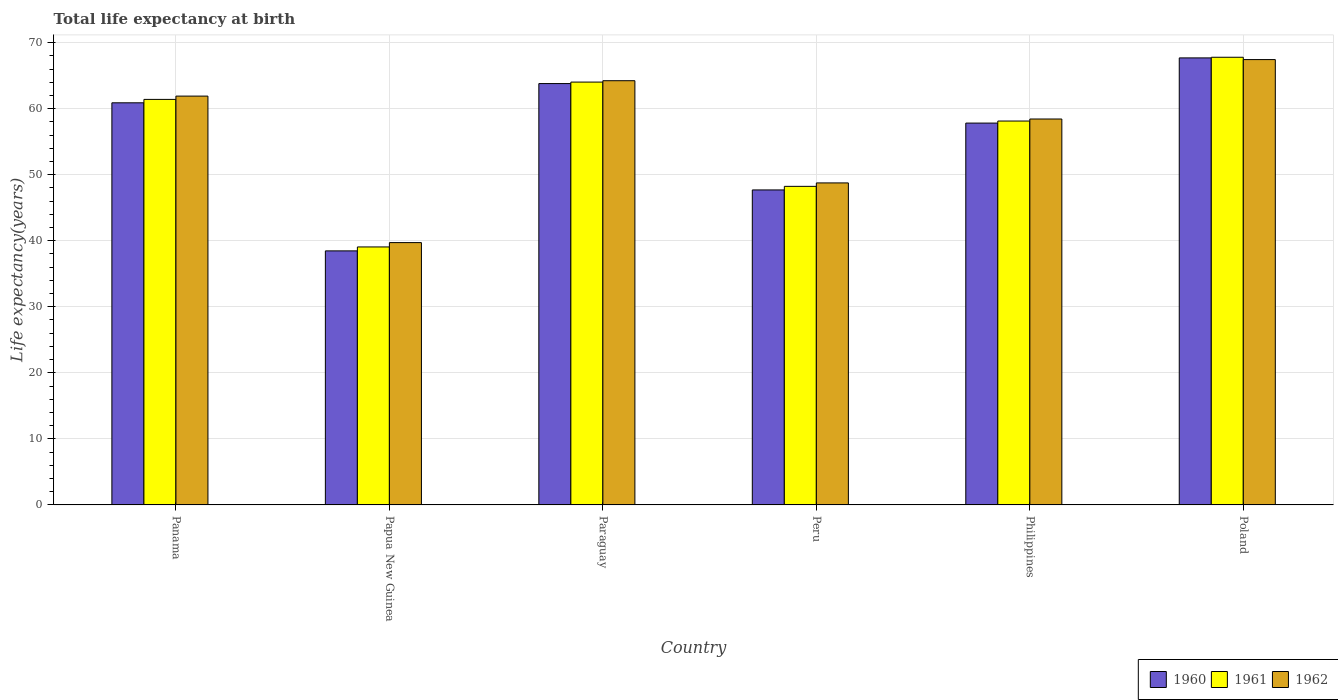How many different coloured bars are there?
Provide a succinct answer. 3. How many groups of bars are there?
Your answer should be very brief. 6. Are the number of bars per tick equal to the number of legend labels?
Offer a terse response. Yes. How many bars are there on the 6th tick from the right?
Offer a terse response. 3. What is the label of the 1st group of bars from the left?
Give a very brief answer. Panama. What is the life expectancy at birth in in 1960 in Panama?
Provide a succinct answer. 60.88. Across all countries, what is the maximum life expectancy at birth in in 1961?
Your answer should be compact. 67.78. Across all countries, what is the minimum life expectancy at birth in in 1961?
Offer a terse response. 39.06. In which country was the life expectancy at birth in in 1960 maximum?
Keep it short and to the point. Poland. In which country was the life expectancy at birth in in 1962 minimum?
Your response must be concise. Papua New Guinea. What is the total life expectancy at birth in in 1962 in the graph?
Offer a very short reply. 340.45. What is the difference between the life expectancy at birth in in 1962 in Panama and that in Papua New Guinea?
Keep it short and to the point. 22.18. What is the difference between the life expectancy at birth in in 1962 in Peru and the life expectancy at birth in in 1961 in Paraguay?
Offer a terse response. -15.27. What is the average life expectancy at birth in in 1961 per country?
Give a very brief answer. 56.43. What is the difference between the life expectancy at birth in of/in 1960 and life expectancy at birth in of/in 1962 in Philippines?
Your answer should be compact. -0.62. What is the ratio of the life expectancy at birth in in 1962 in Panama to that in Peru?
Ensure brevity in your answer.  1.27. What is the difference between the highest and the second highest life expectancy at birth in in 1962?
Offer a terse response. -3.2. What is the difference between the highest and the lowest life expectancy at birth in in 1960?
Provide a succinct answer. 29.22. In how many countries, is the life expectancy at birth in in 1960 greater than the average life expectancy at birth in in 1960 taken over all countries?
Your answer should be very brief. 4. Is the sum of the life expectancy at birth in in 1962 in Panama and Poland greater than the maximum life expectancy at birth in in 1961 across all countries?
Your answer should be very brief. Yes. How many bars are there?
Your response must be concise. 18. Does the graph contain any zero values?
Ensure brevity in your answer.  No. Where does the legend appear in the graph?
Give a very brief answer. Bottom right. What is the title of the graph?
Make the answer very short. Total life expectancy at birth. Does "1987" appear as one of the legend labels in the graph?
Offer a very short reply. No. What is the label or title of the X-axis?
Provide a short and direct response. Country. What is the label or title of the Y-axis?
Give a very brief answer. Life expectancy(years). What is the Life expectancy(years) of 1960 in Panama?
Provide a short and direct response. 60.88. What is the Life expectancy(years) of 1961 in Panama?
Provide a short and direct response. 61.4. What is the Life expectancy(years) in 1962 in Panama?
Your response must be concise. 61.9. What is the Life expectancy(years) of 1960 in Papua New Guinea?
Give a very brief answer. 38.46. What is the Life expectancy(years) of 1961 in Papua New Guinea?
Your answer should be compact. 39.06. What is the Life expectancy(years) of 1962 in Papua New Guinea?
Your answer should be very brief. 39.72. What is the Life expectancy(years) in 1960 in Paraguay?
Ensure brevity in your answer.  63.79. What is the Life expectancy(years) of 1961 in Paraguay?
Provide a short and direct response. 64.02. What is the Life expectancy(years) in 1962 in Paraguay?
Keep it short and to the point. 64.23. What is the Life expectancy(years) in 1960 in Peru?
Provide a succinct answer. 47.69. What is the Life expectancy(years) of 1961 in Peru?
Your answer should be compact. 48.23. What is the Life expectancy(years) of 1962 in Peru?
Provide a short and direct response. 48.75. What is the Life expectancy(years) in 1960 in Philippines?
Your response must be concise. 57.81. What is the Life expectancy(years) of 1961 in Philippines?
Make the answer very short. 58.12. What is the Life expectancy(years) of 1962 in Philippines?
Your answer should be compact. 58.43. What is the Life expectancy(years) in 1960 in Poland?
Give a very brief answer. 67.68. What is the Life expectancy(years) of 1961 in Poland?
Ensure brevity in your answer.  67.78. What is the Life expectancy(years) in 1962 in Poland?
Provide a succinct answer. 67.43. Across all countries, what is the maximum Life expectancy(years) in 1960?
Offer a very short reply. 67.68. Across all countries, what is the maximum Life expectancy(years) in 1961?
Offer a terse response. 67.78. Across all countries, what is the maximum Life expectancy(years) of 1962?
Your answer should be very brief. 67.43. Across all countries, what is the minimum Life expectancy(years) in 1960?
Provide a short and direct response. 38.46. Across all countries, what is the minimum Life expectancy(years) in 1961?
Ensure brevity in your answer.  39.06. Across all countries, what is the minimum Life expectancy(years) in 1962?
Offer a terse response. 39.72. What is the total Life expectancy(years) in 1960 in the graph?
Provide a short and direct response. 336.32. What is the total Life expectancy(years) in 1961 in the graph?
Offer a very short reply. 338.61. What is the total Life expectancy(years) of 1962 in the graph?
Give a very brief answer. 340.45. What is the difference between the Life expectancy(years) in 1960 in Panama and that in Papua New Guinea?
Your answer should be compact. 22.42. What is the difference between the Life expectancy(years) of 1961 in Panama and that in Papua New Guinea?
Your answer should be very brief. 22.34. What is the difference between the Life expectancy(years) in 1962 in Panama and that in Papua New Guinea?
Ensure brevity in your answer.  22.18. What is the difference between the Life expectancy(years) in 1960 in Panama and that in Paraguay?
Offer a terse response. -2.91. What is the difference between the Life expectancy(years) in 1961 in Panama and that in Paraguay?
Your answer should be very brief. -2.62. What is the difference between the Life expectancy(years) of 1962 in Panama and that in Paraguay?
Your response must be concise. -2.33. What is the difference between the Life expectancy(years) in 1960 in Panama and that in Peru?
Your answer should be very brief. 13.19. What is the difference between the Life expectancy(years) of 1961 in Panama and that in Peru?
Ensure brevity in your answer.  13.16. What is the difference between the Life expectancy(years) of 1962 in Panama and that in Peru?
Make the answer very short. 13.14. What is the difference between the Life expectancy(years) of 1960 in Panama and that in Philippines?
Give a very brief answer. 3.07. What is the difference between the Life expectancy(years) in 1961 in Panama and that in Philippines?
Offer a very short reply. 3.28. What is the difference between the Life expectancy(years) of 1962 in Panama and that in Philippines?
Give a very brief answer. 3.47. What is the difference between the Life expectancy(years) of 1960 in Panama and that in Poland?
Your answer should be compact. -6.8. What is the difference between the Life expectancy(years) in 1961 in Panama and that in Poland?
Your answer should be compact. -6.38. What is the difference between the Life expectancy(years) in 1962 in Panama and that in Poland?
Provide a short and direct response. -5.53. What is the difference between the Life expectancy(years) in 1960 in Papua New Guinea and that in Paraguay?
Give a very brief answer. -25.33. What is the difference between the Life expectancy(years) in 1961 in Papua New Guinea and that in Paraguay?
Offer a very short reply. -24.96. What is the difference between the Life expectancy(years) in 1962 in Papua New Guinea and that in Paraguay?
Your answer should be very brief. -24.51. What is the difference between the Life expectancy(years) of 1960 in Papua New Guinea and that in Peru?
Make the answer very short. -9.23. What is the difference between the Life expectancy(years) of 1961 in Papua New Guinea and that in Peru?
Make the answer very short. -9.17. What is the difference between the Life expectancy(years) in 1962 in Papua New Guinea and that in Peru?
Your response must be concise. -9.04. What is the difference between the Life expectancy(years) of 1960 in Papua New Guinea and that in Philippines?
Give a very brief answer. -19.35. What is the difference between the Life expectancy(years) of 1961 in Papua New Guinea and that in Philippines?
Provide a succinct answer. -19.06. What is the difference between the Life expectancy(years) in 1962 in Papua New Guinea and that in Philippines?
Provide a succinct answer. -18.71. What is the difference between the Life expectancy(years) of 1960 in Papua New Guinea and that in Poland?
Ensure brevity in your answer.  -29.22. What is the difference between the Life expectancy(years) in 1961 in Papua New Guinea and that in Poland?
Keep it short and to the point. -28.72. What is the difference between the Life expectancy(years) in 1962 in Papua New Guinea and that in Poland?
Your response must be concise. -27.71. What is the difference between the Life expectancy(years) of 1960 in Paraguay and that in Peru?
Your response must be concise. 16.1. What is the difference between the Life expectancy(years) of 1961 in Paraguay and that in Peru?
Ensure brevity in your answer.  15.79. What is the difference between the Life expectancy(years) in 1962 in Paraguay and that in Peru?
Provide a short and direct response. 15.47. What is the difference between the Life expectancy(years) in 1960 in Paraguay and that in Philippines?
Ensure brevity in your answer.  5.98. What is the difference between the Life expectancy(years) of 1961 in Paraguay and that in Philippines?
Give a very brief answer. 5.9. What is the difference between the Life expectancy(years) in 1962 in Paraguay and that in Philippines?
Give a very brief answer. 5.8. What is the difference between the Life expectancy(years) of 1960 in Paraguay and that in Poland?
Offer a terse response. -3.89. What is the difference between the Life expectancy(years) in 1961 in Paraguay and that in Poland?
Ensure brevity in your answer.  -3.76. What is the difference between the Life expectancy(years) of 1962 in Paraguay and that in Poland?
Provide a short and direct response. -3.2. What is the difference between the Life expectancy(years) in 1960 in Peru and that in Philippines?
Provide a short and direct response. -10.12. What is the difference between the Life expectancy(years) in 1961 in Peru and that in Philippines?
Your answer should be compact. -9.89. What is the difference between the Life expectancy(years) in 1962 in Peru and that in Philippines?
Keep it short and to the point. -9.68. What is the difference between the Life expectancy(years) in 1960 in Peru and that in Poland?
Ensure brevity in your answer.  -19.99. What is the difference between the Life expectancy(years) of 1961 in Peru and that in Poland?
Provide a short and direct response. -19.55. What is the difference between the Life expectancy(years) in 1962 in Peru and that in Poland?
Provide a succinct answer. -18.67. What is the difference between the Life expectancy(years) in 1960 in Philippines and that in Poland?
Offer a terse response. -9.87. What is the difference between the Life expectancy(years) in 1961 in Philippines and that in Poland?
Provide a short and direct response. -9.66. What is the difference between the Life expectancy(years) of 1962 in Philippines and that in Poland?
Your answer should be very brief. -9. What is the difference between the Life expectancy(years) in 1960 in Panama and the Life expectancy(years) in 1961 in Papua New Guinea?
Offer a very short reply. 21.82. What is the difference between the Life expectancy(years) in 1960 in Panama and the Life expectancy(years) in 1962 in Papua New Guinea?
Your response must be concise. 21.16. What is the difference between the Life expectancy(years) in 1961 in Panama and the Life expectancy(years) in 1962 in Papua New Guinea?
Your response must be concise. 21.68. What is the difference between the Life expectancy(years) in 1960 in Panama and the Life expectancy(years) in 1961 in Paraguay?
Give a very brief answer. -3.14. What is the difference between the Life expectancy(years) in 1960 in Panama and the Life expectancy(years) in 1962 in Paraguay?
Your response must be concise. -3.35. What is the difference between the Life expectancy(years) in 1961 in Panama and the Life expectancy(years) in 1962 in Paraguay?
Keep it short and to the point. -2.83. What is the difference between the Life expectancy(years) of 1960 in Panama and the Life expectancy(years) of 1961 in Peru?
Give a very brief answer. 12.65. What is the difference between the Life expectancy(years) of 1960 in Panama and the Life expectancy(years) of 1962 in Peru?
Make the answer very short. 12.13. What is the difference between the Life expectancy(years) of 1961 in Panama and the Life expectancy(years) of 1962 in Peru?
Your response must be concise. 12.64. What is the difference between the Life expectancy(years) of 1960 in Panama and the Life expectancy(years) of 1961 in Philippines?
Provide a succinct answer. 2.76. What is the difference between the Life expectancy(years) in 1960 in Panama and the Life expectancy(years) in 1962 in Philippines?
Offer a terse response. 2.45. What is the difference between the Life expectancy(years) in 1961 in Panama and the Life expectancy(years) in 1962 in Philippines?
Keep it short and to the point. 2.97. What is the difference between the Life expectancy(years) in 1960 in Panama and the Life expectancy(years) in 1961 in Poland?
Your response must be concise. -6.9. What is the difference between the Life expectancy(years) of 1960 in Panama and the Life expectancy(years) of 1962 in Poland?
Keep it short and to the point. -6.55. What is the difference between the Life expectancy(years) in 1961 in Panama and the Life expectancy(years) in 1962 in Poland?
Your answer should be very brief. -6.03. What is the difference between the Life expectancy(years) in 1960 in Papua New Guinea and the Life expectancy(years) in 1961 in Paraguay?
Provide a succinct answer. -25.56. What is the difference between the Life expectancy(years) of 1960 in Papua New Guinea and the Life expectancy(years) of 1962 in Paraguay?
Provide a short and direct response. -25.76. What is the difference between the Life expectancy(years) of 1961 in Papua New Guinea and the Life expectancy(years) of 1962 in Paraguay?
Provide a short and direct response. -25.17. What is the difference between the Life expectancy(years) of 1960 in Papua New Guinea and the Life expectancy(years) of 1961 in Peru?
Ensure brevity in your answer.  -9.77. What is the difference between the Life expectancy(years) of 1960 in Papua New Guinea and the Life expectancy(years) of 1962 in Peru?
Offer a terse response. -10.29. What is the difference between the Life expectancy(years) in 1961 in Papua New Guinea and the Life expectancy(years) in 1962 in Peru?
Offer a terse response. -9.69. What is the difference between the Life expectancy(years) in 1960 in Papua New Guinea and the Life expectancy(years) in 1961 in Philippines?
Your answer should be very brief. -19.66. What is the difference between the Life expectancy(years) in 1960 in Papua New Guinea and the Life expectancy(years) in 1962 in Philippines?
Give a very brief answer. -19.97. What is the difference between the Life expectancy(years) of 1961 in Papua New Guinea and the Life expectancy(years) of 1962 in Philippines?
Give a very brief answer. -19.37. What is the difference between the Life expectancy(years) of 1960 in Papua New Guinea and the Life expectancy(years) of 1961 in Poland?
Your answer should be very brief. -29.32. What is the difference between the Life expectancy(years) of 1960 in Papua New Guinea and the Life expectancy(years) of 1962 in Poland?
Your response must be concise. -28.96. What is the difference between the Life expectancy(years) in 1961 in Papua New Guinea and the Life expectancy(years) in 1962 in Poland?
Your answer should be very brief. -28.37. What is the difference between the Life expectancy(years) in 1960 in Paraguay and the Life expectancy(years) in 1961 in Peru?
Make the answer very short. 15.56. What is the difference between the Life expectancy(years) of 1960 in Paraguay and the Life expectancy(years) of 1962 in Peru?
Your response must be concise. 15.04. What is the difference between the Life expectancy(years) of 1961 in Paraguay and the Life expectancy(years) of 1962 in Peru?
Ensure brevity in your answer.  15.27. What is the difference between the Life expectancy(years) of 1960 in Paraguay and the Life expectancy(years) of 1961 in Philippines?
Your answer should be compact. 5.67. What is the difference between the Life expectancy(years) of 1960 in Paraguay and the Life expectancy(years) of 1962 in Philippines?
Provide a short and direct response. 5.36. What is the difference between the Life expectancy(years) of 1961 in Paraguay and the Life expectancy(years) of 1962 in Philippines?
Provide a succinct answer. 5.59. What is the difference between the Life expectancy(years) in 1960 in Paraguay and the Life expectancy(years) in 1961 in Poland?
Provide a short and direct response. -3.98. What is the difference between the Life expectancy(years) of 1960 in Paraguay and the Life expectancy(years) of 1962 in Poland?
Keep it short and to the point. -3.63. What is the difference between the Life expectancy(years) in 1961 in Paraguay and the Life expectancy(years) in 1962 in Poland?
Provide a succinct answer. -3.41. What is the difference between the Life expectancy(years) in 1960 in Peru and the Life expectancy(years) in 1961 in Philippines?
Give a very brief answer. -10.43. What is the difference between the Life expectancy(years) in 1960 in Peru and the Life expectancy(years) in 1962 in Philippines?
Offer a very short reply. -10.74. What is the difference between the Life expectancy(years) in 1961 in Peru and the Life expectancy(years) in 1962 in Philippines?
Offer a terse response. -10.2. What is the difference between the Life expectancy(years) in 1960 in Peru and the Life expectancy(years) in 1961 in Poland?
Your answer should be very brief. -20.09. What is the difference between the Life expectancy(years) in 1960 in Peru and the Life expectancy(years) in 1962 in Poland?
Give a very brief answer. -19.74. What is the difference between the Life expectancy(years) of 1961 in Peru and the Life expectancy(years) of 1962 in Poland?
Your answer should be very brief. -19.19. What is the difference between the Life expectancy(years) in 1960 in Philippines and the Life expectancy(years) in 1961 in Poland?
Provide a short and direct response. -9.97. What is the difference between the Life expectancy(years) of 1960 in Philippines and the Life expectancy(years) of 1962 in Poland?
Give a very brief answer. -9.61. What is the difference between the Life expectancy(years) in 1961 in Philippines and the Life expectancy(years) in 1962 in Poland?
Offer a terse response. -9.3. What is the average Life expectancy(years) of 1960 per country?
Offer a terse response. 56.05. What is the average Life expectancy(years) of 1961 per country?
Your answer should be very brief. 56.43. What is the average Life expectancy(years) of 1962 per country?
Make the answer very short. 56.74. What is the difference between the Life expectancy(years) in 1960 and Life expectancy(years) in 1961 in Panama?
Ensure brevity in your answer.  -0.52. What is the difference between the Life expectancy(years) in 1960 and Life expectancy(years) in 1962 in Panama?
Provide a succinct answer. -1.01. What is the difference between the Life expectancy(years) in 1961 and Life expectancy(years) in 1962 in Panama?
Offer a very short reply. -0.5. What is the difference between the Life expectancy(years) in 1960 and Life expectancy(years) in 1961 in Papua New Guinea?
Make the answer very short. -0.6. What is the difference between the Life expectancy(years) in 1960 and Life expectancy(years) in 1962 in Papua New Guinea?
Your answer should be compact. -1.26. What is the difference between the Life expectancy(years) of 1961 and Life expectancy(years) of 1962 in Papua New Guinea?
Make the answer very short. -0.66. What is the difference between the Life expectancy(years) in 1960 and Life expectancy(years) in 1961 in Paraguay?
Offer a very short reply. -0.22. What is the difference between the Life expectancy(years) in 1960 and Life expectancy(years) in 1962 in Paraguay?
Provide a short and direct response. -0.43. What is the difference between the Life expectancy(years) in 1961 and Life expectancy(years) in 1962 in Paraguay?
Ensure brevity in your answer.  -0.21. What is the difference between the Life expectancy(years) in 1960 and Life expectancy(years) in 1961 in Peru?
Your response must be concise. -0.54. What is the difference between the Life expectancy(years) in 1960 and Life expectancy(years) in 1962 in Peru?
Ensure brevity in your answer.  -1.06. What is the difference between the Life expectancy(years) in 1961 and Life expectancy(years) in 1962 in Peru?
Provide a succinct answer. -0.52. What is the difference between the Life expectancy(years) of 1960 and Life expectancy(years) of 1961 in Philippines?
Keep it short and to the point. -0.31. What is the difference between the Life expectancy(years) in 1960 and Life expectancy(years) in 1962 in Philippines?
Your answer should be compact. -0.62. What is the difference between the Life expectancy(years) in 1961 and Life expectancy(years) in 1962 in Philippines?
Your response must be concise. -0.31. What is the difference between the Life expectancy(years) of 1960 and Life expectancy(years) of 1961 in Poland?
Your response must be concise. -0.1. What is the difference between the Life expectancy(years) in 1960 and Life expectancy(years) in 1962 in Poland?
Offer a very short reply. 0.25. What is the difference between the Life expectancy(years) of 1961 and Life expectancy(years) of 1962 in Poland?
Offer a very short reply. 0.35. What is the ratio of the Life expectancy(years) of 1960 in Panama to that in Papua New Guinea?
Your answer should be very brief. 1.58. What is the ratio of the Life expectancy(years) of 1961 in Panama to that in Papua New Guinea?
Keep it short and to the point. 1.57. What is the ratio of the Life expectancy(years) of 1962 in Panama to that in Papua New Guinea?
Provide a succinct answer. 1.56. What is the ratio of the Life expectancy(years) of 1960 in Panama to that in Paraguay?
Ensure brevity in your answer.  0.95. What is the ratio of the Life expectancy(years) of 1961 in Panama to that in Paraguay?
Offer a very short reply. 0.96. What is the ratio of the Life expectancy(years) of 1962 in Panama to that in Paraguay?
Keep it short and to the point. 0.96. What is the ratio of the Life expectancy(years) in 1960 in Panama to that in Peru?
Make the answer very short. 1.28. What is the ratio of the Life expectancy(years) of 1961 in Panama to that in Peru?
Your answer should be compact. 1.27. What is the ratio of the Life expectancy(years) in 1962 in Panama to that in Peru?
Provide a succinct answer. 1.27. What is the ratio of the Life expectancy(years) of 1960 in Panama to that in Philippines?
Give a very brief answer. 1.05. What is the ratio of the Life expectancy(years) of 1961 in Panama to that in Philippines?
Provide a succinct answer. 1.06. What is the ratio of the Life expectancy(years) of 1962 in Panama to that in Philippines?
Your answer should be compact. 1.06. What is the ratio of the Life expectancy(years) of 1960 in Panama to that in Poland?
Keep it short and to the point. 0.9. What is the ratio of the Life expectancy(years) of 1961 in Panama to that in Poland?
Your answer should be compact. 0.91. What is the ratio of the Life expectancy(years) of 1962 in Panama to that in Poland?
Provide a short and direct response. 0.92. What is the ratio of the Life expectancy(years) in 1960 in Papua New Guinea to that in Paraguay?
Offer a terse response. 0.6. What is the ratio of the Life expectancy(years) of 1961 in Papua New Guinea to that in Paraguay?
Your response must be concise. 0.61. What is the ratio of the Life expectancy(years) of 1962 in Papua New Guinea to that in Paraguay?
Offer a terse response. 0.62. What is the ratio of the Life expectancy(years) of 1960 in Papua New Guinea to that in Peru?
Your answer should be compact. 0.81. What is the ratio of the Life expectancy(years) in 1961 in Papua New Guinea to that in Peru?
Offer a terse response. 0.81. What is the ratio of the Life expectancy(years) in 1962 in Papua New Guinea to that in Peru?
Your response must be concise. 0.81. What is the ratio of the Life expectancy(years) of 1960 in Papua New Guinea to that in Philippines?
Your answer should be very brief. 0.67. What is the ratio of the Life expectancy(years) of 1961 in Papua New Guinea to that in Philippines?
Provide a succinct answer. 0.67. What is the ratio of the Life expectancy(years) in 1962 in Papua New Guinea to that in Philippines?
Provide a succinct answer. 0.68. What is the ratio of the Life expectancy(years) in 1960 in Papua New Guinea to that in Poland?
Provide a short and direct response. 0.57. What is the ratio of the Life expectancy(years) of 1961 in Papua New Guinea to that in Poland?
Keep it short and to the point. 0.58. What is the ratio of the Life expectancy(years) in 1962 in Papua New Guinea to that in Poland?
Give a very brief answer. 0.59. What is the ratio of the Life expectancy(years) in 1960 in Paraguay to that in Peru?
Your answer should be very brief. 1.34. What is the ratio of the Life expectancy(years) in 1961 in Paraguay to that in Peru?
Your answer should be very brief. 1.33. What is the ratio of the Life expectancy(years) in 1962 in Paraguay to that in Peru?
Offer a very short reply. 1.32. What is the ratio of the Life expectancy(years) of 1960 in Paraguay to that in Philippines?
Your answer should be very brief. 1.1. What is the ratio of the Life expectancy(years) of 1961 in Paraguay to that in Philippines?
Offer a very short reply. 1.1. What is the ratio of the Life expectancy(years) in 1962 in Paraguay to that in Philippines?
Your answer should be compact. 1.1. What is the ratio of the Life expectancy(years) in 1960 in Paraguay to that in Poland?
Make the answer very short. 0.94. What is the ratio of the Life expectancy(years) of 1961 in Paraguay to that in Poland?
Offer a very short reply. 0.94. What is the ratio of the Life expectancy(years) of 1962 in Paraguay to that in Poland?
Your response must be concise. 0.95. What is the ratio of the Life expectancy(years) in 1960 in Peru to that in Philippines?
Your answer should be compact. 0.82. What is the ratio of the Life expectancy(years) of 1961 in Peru to that in Philippines?
Your response must be concise. 0.83. What is the ratio of the Life expectancy(years) in 1962 in Peru to that in Philippines?
Your answer should be very brief. 0.83. What is the ratio of the Life expectancy(years) in 1960 in Peru to that in Poland?
Your response must be concise. 0.7. What is the ratio of the Life expectancy(years) in 1961 in Peru to that in Poland?
Offer a terse response. 0.71. What is the ratio of the Life expectancy(years) in 1962 in Peru to that in Poland?
Ensure brevity in your answer.  0.72. What is the ratio of the Life expectancy(years) of 1960 in Philippines to that in Poland?
Provide a short and direct response. 0.85. What is the ratio of the Life expectancy(years) in 1961 in Philippines to that in Poland?
Provide a short and direct response. 0.86. What is the ratio of the Life expectancy(years) in 1962 in Philippines to that in Poland?
Offer a terse response. 0.87. What is the difference between the highest and the second highest Life expectancy(years) of 1960?
Keep it short and to the point. 3.89. What is the difference between the highest and the second highest Life expectancy(years) in 1961?
Make the answer very short. 3.76. What is the difference between the highest and the second highest Life expectancy(years) in 1962?
Keep it short and to the point. 3.2. What is the difference between the highest and the lowest Life expectancy(years) of 1960?
Provide a succinct answer. 29.22. What is the difference between the highest and the lowest Life expectancy(years) of 1961?
Your answer should be compact. 28.72. What is the difference between the highest and the lowest Life expectancy(years) in 1962?
Your response must be concise. 27.71. 